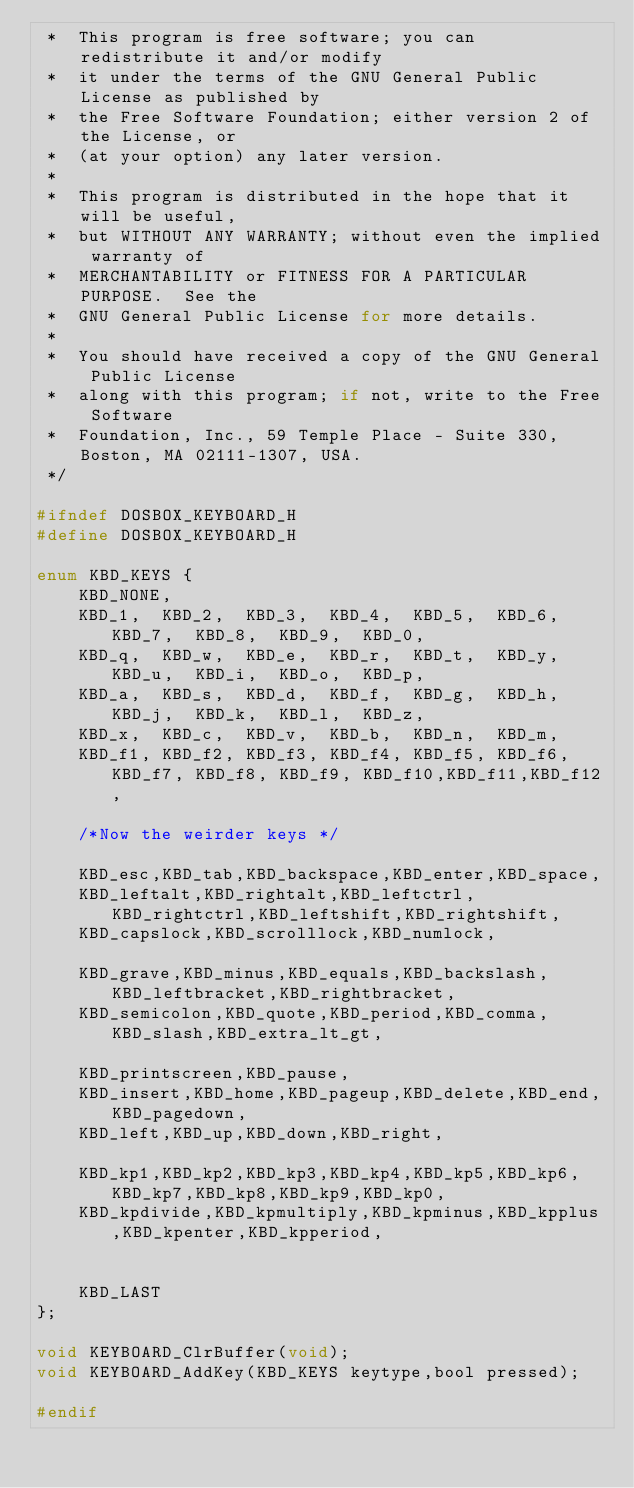Convert code to text. <code><loc_0><loc_0><loc_500><loc_500><_C_> *  This program is free software; you can redistribute it and/or modify
 *  it under the terms of the GNU General Public License as published by
 *  the Free Software Foundation; either version 2 of the License, or
 *  (at your option) any later version.
 *
 *  This program is distributed in the hope that it will be useful,
 *  but WITHOUT ANY WARRANTY; without even the implied warranty of
 *  MERCHANTABILITY or FITNESS FOR A PARTICULAR PURPOSE.  See the
 *  GNU General Public License for more details.
 *
 *  You should have received a copy of the GNU General Public License
 *  along with this program; if not, write to the Free Software
 *  Foundation, Inc., 59 Temple Place - Suite 330, Boston, MA 02111-1307, USA.
 */

#ifndef DOSBOX_KEYBOARD_H
#define DOSBOX_KEYBOARD_H

enum KBD_KEYS {
	KBD_NONE,
	KBD_1,	KBD_2,	KBD_3,	KBD_4,	KBD_5,	KBD_6,	KBD_7,	KBD_8,	KBD_9,	KBD_0,		
	KBD_q,	KBD_w,	KBD_e,	KBD_r,	KBD_t,	KBD_y,	KBD_u,	KBD_i,	KBD_o,	KBD_p,	
	KBD_a,	KBD_s,	KBD_d,	KBD_f,	KBD_g,	KBD_h,	KBD_j,	KBD_k,	KBD_l,	KBD_z,
	KBD_x,	KBD_c,	KBD_v,	KBD_b,	KBD_n,	KBD_m,	
	KBD_f1,	KBD_f2,	KBD_f3,	KBD_f4,	KBD_f5,	KBD_f6,	KBD_f7,	KBD_f8,	KBD_f9,	KBD_f10,KBD_f11,KBD_f12,
	
	/*Now the weirder keys */

	KBD_esc,KBD_tab,KBD_backspace,KBD_enter,KBD_space,
	KBD_leftalt,KBD_rightalt,KBD_leftctrl,KBD_rightctrl,KBD_leftshift,KBD_rightshift,
	KBD_capslock,KBD_scrolllock,KBD_numlock,
	
	KBD_grave,KBD_minus,KBD_equals,KBD_backslash,KBD_leftbracket,KBD_rightbracket,
	KBD_semicolon,KBD_quote,KBD_period,KBD_comma,KBD_slash,KBD_extra_lt_gt,

	KBD_printscreen,KBD_pause,
	KBD_insert,KBD_home,KBD_pageup,KBD_delete,KBD_end,KBD_pagedown,
	KBD_left,KBD_up,KBD_down,KBD_right,

	KBD_kp1,KBD_kp2,KBD_kp3,KBD_kp4,KBD_kp5,KBD_kp6,KBD_kp7,KBD_kp8,KBD_kp9,KBD_kp0,
	KBD_kpdivide,KBD_kpmultiply,KBD_kpminus,KBD_kpplus,KBD_kpenter,KBD_kpperiod,

	
	KBD_LAST
};

void KEYBOARD_ClrBuffer(void);
void KEYBOARD_AddKey(KBD_KEYS keytype,bool pressed);

#endif
</code> 